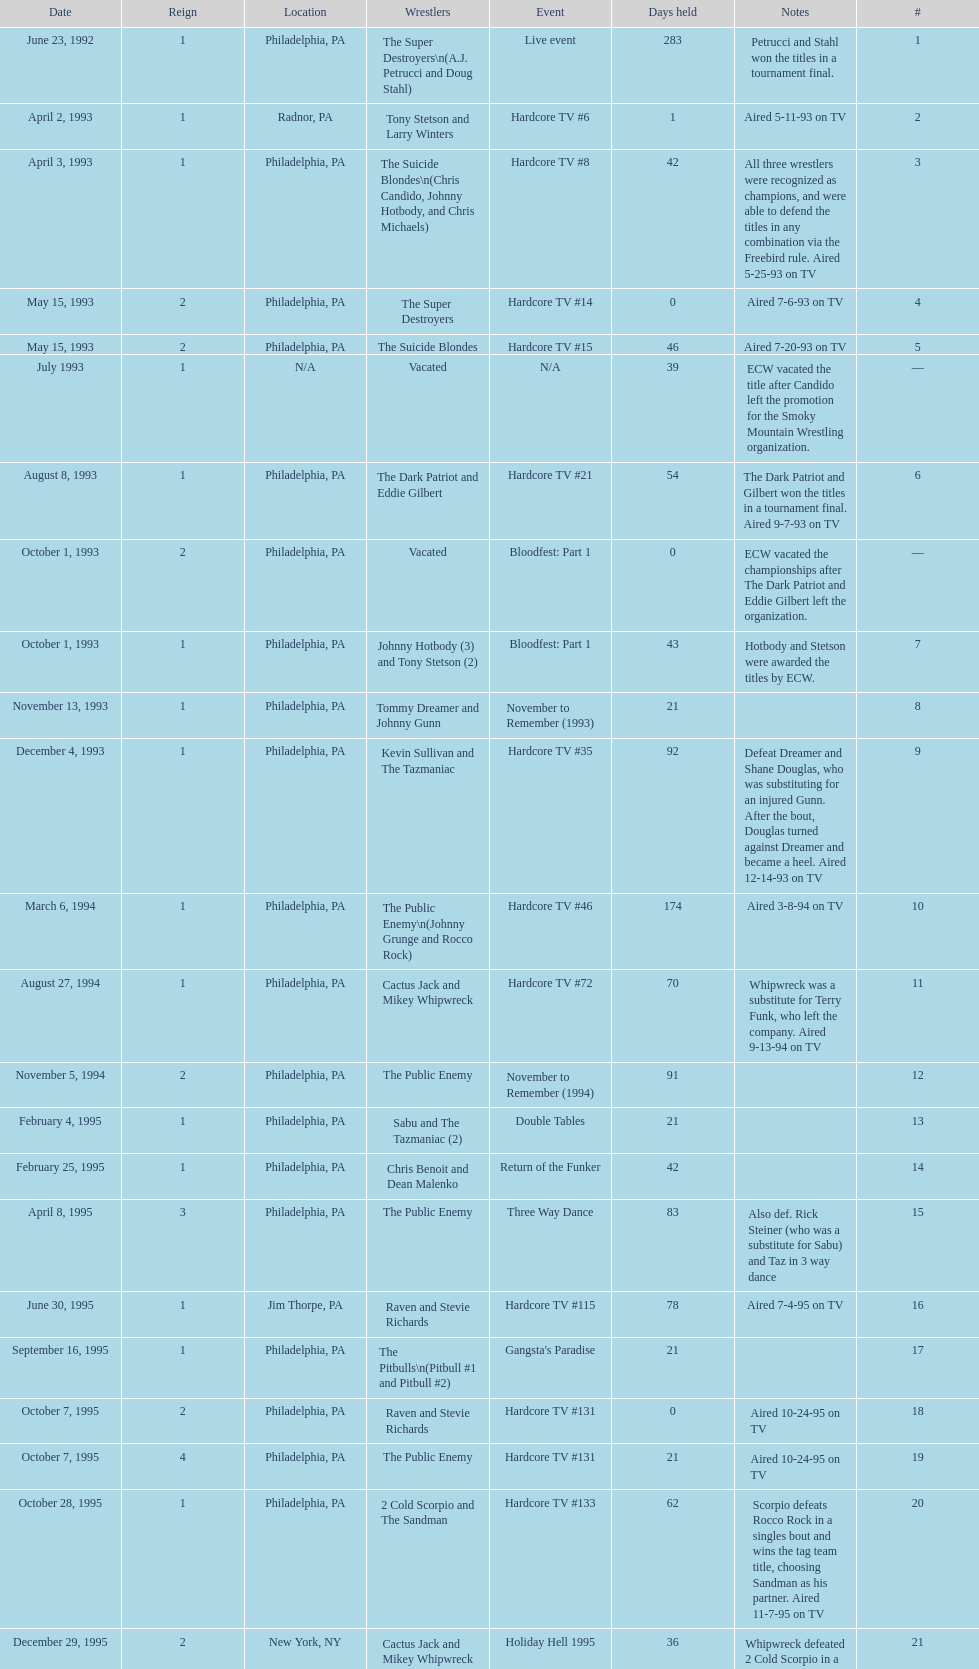What event comes before hardcore tv #14? Hardcore TV #8. 